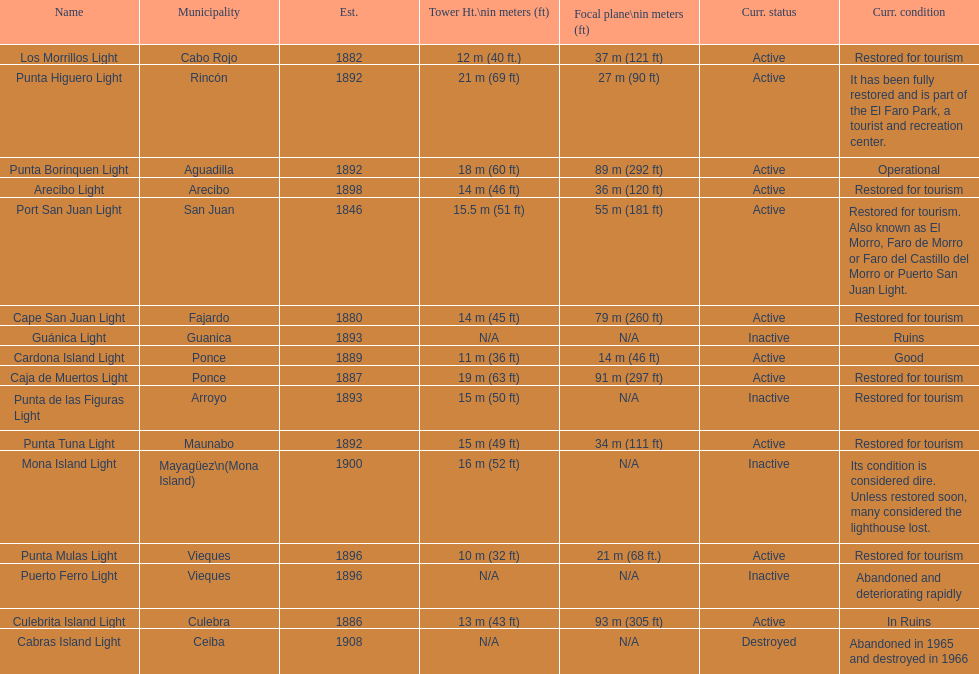What is the count of lighthouses with names that start with a "p"? 7. 